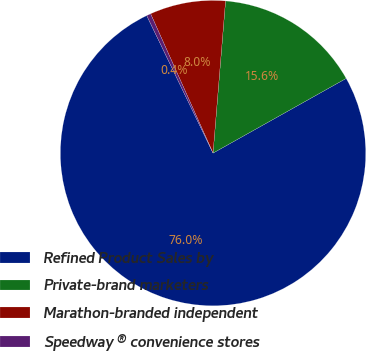Convert chart. <chart><loc_0><loc_0><loc_500><loc_500><pie_chart><fcel>Refined Product Sales by<fcel>Private-brand marketers<fcel>Marathon-branded independent<fcel>Speedway ® convenience stores<nl><fcel>75.98%<fcel>15.56%<fcel>8.01%<fcel>0.45%<nl></chart> 